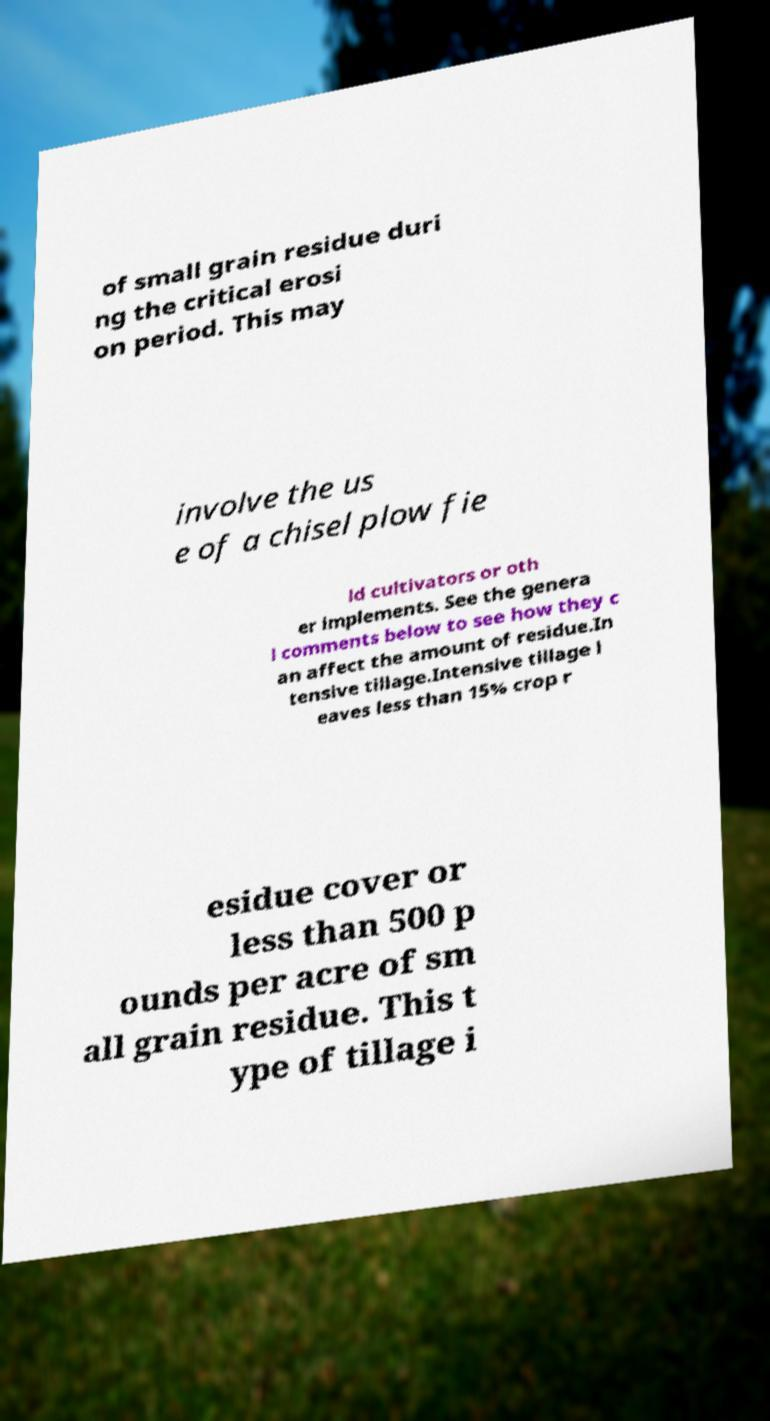Please read and relay the text visible in this image. What does it say? of small grain residue duri ng the critical erosi on period. This may involve the us e of a chisel plow fie ld cultivators or oth er implements. See the genera l comments below to see how they c an affect the amount of residue.In tensive tillage.Intensive tillage l eaves less than 15% crop r esidue cover or less than 500 p ounds per acre of sm all grain residue. This t ype of tillage i 